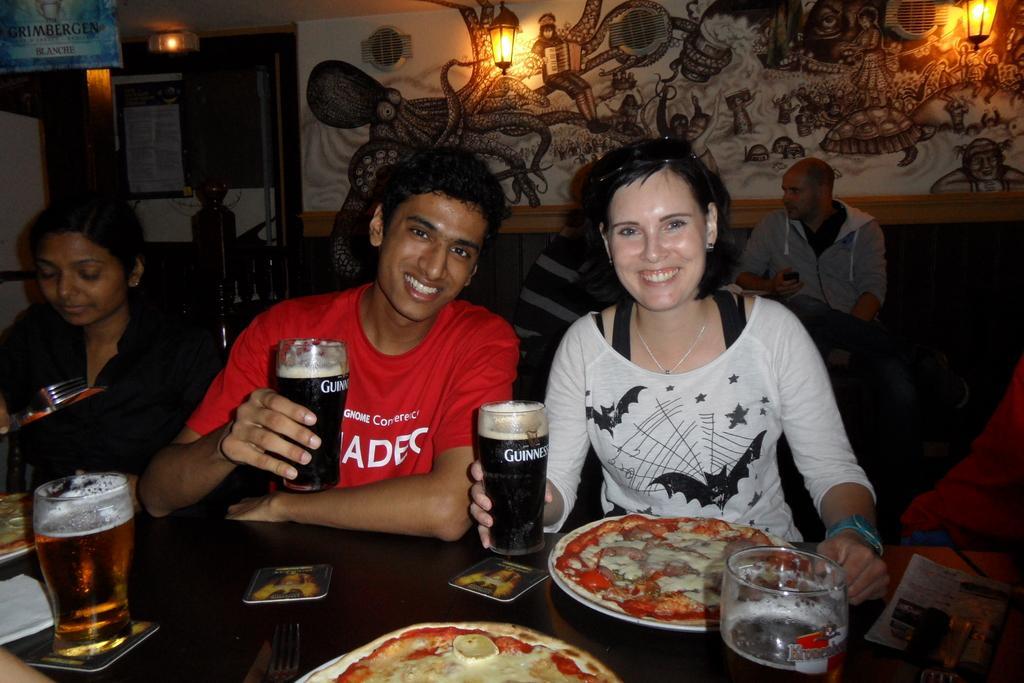Please provide a concise description of this image. In the picture we can find a set of people, a man and women are sitting on a chairs near the table and holding a wine glasses, on a table we can find a plate food, in a background we can find a designs on wall and lights. 